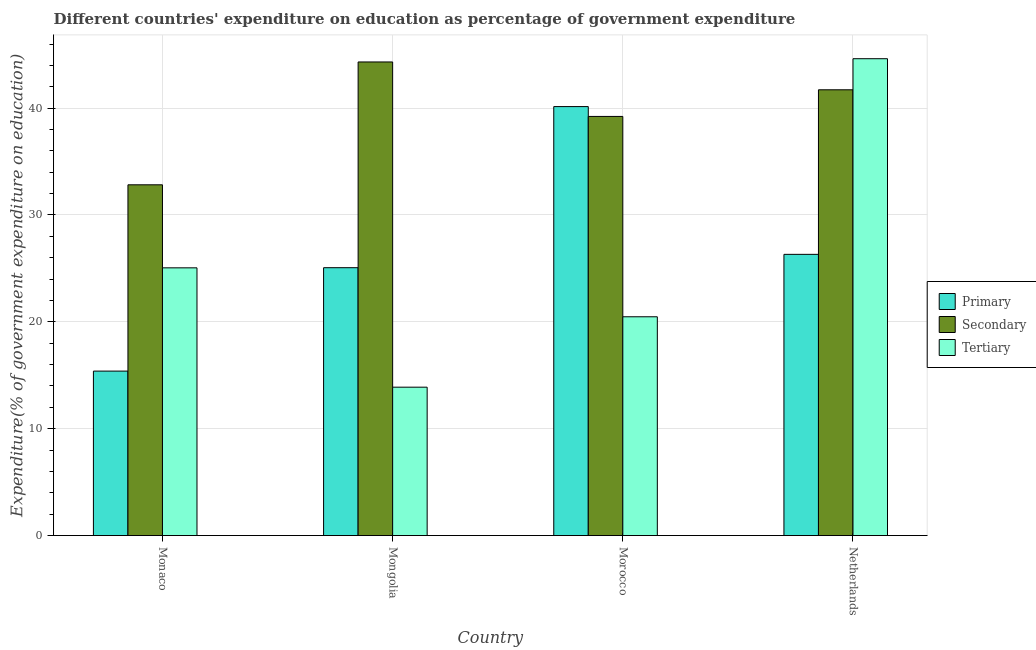How many different coloured bars are there?
Offer a very short reply. 3. Are the number of bars per tick equal to the number of legend labels?
Provide a short and direct response. Yes. Are the number of bars on each tick of the X-axis equal?
Your answer should be compact. Yes. How many bars are there on the 3rd tick from the right?
Provide a short and direct response. 3. What is the label of the 3rd group of bars from the left?
Keep it short and to the point. Morocco. In how many cases, is the number of bars for a given country not equal to the number of legend labels?
Your answer should be compact. 0. What is the expenditure on secondary education in Monaco?
Ensure brevity in your answer.  32.83. Across all countries, what is the maximum expenditure on tertiary education?
Ensure brevity in your answer.  44.63. Across all countries, what is the minimum expenditure on primary education?
Make the answer very short. 15.39. In which country was the expenditure on tertiary education maximum?
Your answer should be compact. Netherlands. In which country was the expenditure on secondary education minimum?
Your response must be concise. Monaco. What is the total expenditure on primary education in the graph?
Your answer should be compact. 106.92. What is the difference between the expenditure on secondary education in Mongolia and that in Netherlands?
Your response must be concise. 2.6. What is the difference between the expenditure on secondary education in Morocco and the expenditure on primary education in Monaco?
Your response must be concise. 23.83. What is the average expenditure on primary education per country?
Keep it short and to the point. 26.73. What is the difference between the expenditure on primary education and expenditure on tertiary education in Netherlands?
Offer a terse response. -18.31. What is the ratio of the expenditure on primary education in Monaco to that in Netherlands?
Provide a succinct answer. 0.58. Is the expenditure on primary education in Monaco less than that in Morocco?
Keep it short and to the point. Yes. Is the difference between the expenditure on primary education in Mongolia and Netherlands greater than the difference between the expenditure on secondary education in Mongolia and Netherlands?
Ensure brevity in your answer.  No. What is the difference between the highest and the second highest expenditure on tertiary education?
Give a very brief answer. 19.57. What is the difference between the highest and the lowest expenditure on tertiary education?
Your answer should be compact. 30.74. In how many countries, is the expenditure on secondary education greater than the average expenditure on secondary education taken over all countries?
Keep it short and to the point. 2. What does the 1st bar from the left in Morocco represents?
Keep it short and to the point. Primary. What does the 3rd bar from the right in Netherlands represents?
Your answer should be compact. Primary. Are all the bars in the graph horizontal?
Give a very brief answer. No. How many countries are there in the graph?
Provide a short and direct response. 4. What is the difference between two consecutive major ticks on the Y-axis?
Make the answer very short. 10. Are the values on the major ticks of Y-axis written in scientific E-notation?
Provide a short and direct response. No. What is the title of the graph?
Your response must be concise. Different countries' expenditure on education as percentage of government expenditure. Does "Poland" appear as one of the legend labels in the graph?
Keep it short and to the point. No. What is the label or title of the X-axis?
Your response must be concise. Country. What is the label or title of the Y-axis?
Give a very brief answer. Expenditure(% of government expenditure on education). What is the Expenditure(% of government expenditure on education) of Primary in Monaco?
Give a very brief answer. 15.39. What is the Expenditure(% of government expenditure on education) in Secondary in Monaco?
Offer a very short reply. 32.83. What is the Expenditure(% of government expenditure on education) in Tertiary in Monaco?
Give a very brief answer. 25.05. What is the Expenditure(% of government expenditure on education) in Primary in Mongolia?
Offer a terse response. 25.07. What is the Expenditure(% of government expenditure on education) of Secondary in Mongolia?
Make the answer very short. 44.32. What is the Expenditure(% of government expenditure on education) in Tertiary in Mongolia?
Provide a succinct answer. 13.89. What is the Expenditure(% of government expenditure on education) of Primary in Morocco?
Provide a short and direct response. 40.15. What is the Expenditure(% of government expenditure on education) of Secondary in Morocco?
Ensure brevity in your answer.  39.22. What is the Expenditure(% of government expenditure on education) of Tertiary in Morocco?
Offer a very short reply. 20.47. What is the Expenditure(% of government expenditure on education) in Primary in Netherlands?
Keep it short and to the point. 26.32. What is the Expenditure(% of government expenditure on education) of Secondary in Netherlands?
Keep it short and to the point. 41.72. What is the Expenditure(% of government expenditure on education) of Tertiary in Netherlands?
Offer a terse response. 44.63. Across all countries, what is the maximum Expenditure(% of government expenditure on education) of Primary?
Your response must be concise. 40.15. Across all countries, what is the maximum Expenditure(% of government expenditure on education) of Secondary?
Offer a terse response. 44.32. Across all countries, what is the maximum Expenditure(% of government expenditure on education) in Tertiary?
Keep it short and to the point. 44.63. Across all countries, what is the minimum Expenditure(% of government expenditure on education) of Primary?
Keep it short and to the point. 15.39. Across all countries, what is the minimum Expenditure(% of government expenditure on education) of Secondary?
Keep it short and to the point. 32.83. Across all countries, what is the minimum Expenditure(% of government expenditure on education) of Tertiary?
Provide a short and direct response. 13.89. What is the total Expenditure(% of government expenditure on education) in Primary in the graph?
Offer a very short reply. 106.92. What is the total Expenditure(% of government expenditure on education) in Secondary in the graph?
Provide a short and direct response. 158.09. What is the total Expenditure(% of government expenditure on education) in Tertiary in the graph?
Provide a short and direct response. 104.04. What is the difference between the Expenditure(% of government expenditure on education) of Primary in Monaco and that in Mongolia?
Give a very brief answer. -9.68. What is the difference between the Expenditure(% of government expenditure on education) in Secondary in Monaco and that in Mongolia?
Make the answer very short. -11.5. What is the difference between the Expenditure(% of government expenditure on education) of Tertiary in Monaco and that in Mongolia?
Your answer should be very brief. 11.17. What is the difference between the Expenditure(% of government expenditure on education) in Primary in Monaco and that in Morocco?
Keep it short and to the point. -24.75. What is the difference between the Expenditure(% of government expenditure on education) in Secondary in Monaco and that in Morocco?
Provide a succinct answer. -6.4. What is the difference between the Expenditure(% of government expenditure on education) of Tertiary in Monaco and that in Morocco?
Provide a succinct answer. 4.58. What is the difference between the Expenditure(% of government expenditure on education) in Primary in Monaco and that in Netherlands?
Your answer should be compact. -10.93. What is the difference between the Expenditure(% of government expenditure on education) of Secondary in Monaco and that in Netherlands?
Your response must be concise. -8.89. What is the difference between the Expenditure(% of government expenditure on education) in Tertiary in Monaco and that in Netherlands?
Make the answer very short. -19.57. What is the difference between the Expenditure(% of government expenditure on education) of Primary in Mongolia and that in Morocco?
Provide a short and direct response. -15.08. What is the difference between the Expenditure(% of government expenditure on education) in Secondary in Mongolia and that in Morocco?
Your response must be concise. 5.1. What is the difference between the Expenditure(% of government expenditure on education) of Tertiary in Mongolia and that in Morocco?
Your response must be concise. -6.59. What is the difference between the Expenditure(% of government expenditure on education) of Primary in Mongolia and that in Netherlands?
Your answer should be compact. -1.25. What is the difference between the Expenditure(% of government expenditure on education) of Secondary in Mongolia and that in Netherlands?
Your answer should be very brief. 2.6. What is the difference between the Expenditure(% of government expenditure on education) in Tertiary in Mongolia and that in Netherlands?
Provide a short and direct response. -30.74. What is the difference between the Expenditure(% of government expenditure on education) of Primary in Morocco and that in Netherlands?
Keep it short and to the point. 13.83. What is the difference between the Expenditure(% of government expenditure on education) of Secondary in Morocco and that in Netherlands?
Offer a terse response. -2.49. What is the difference between the Expenditure(% of government expenditure on education) of Tertiary in Morocco and that in Netherlands?
Give a very brief answer. -24.15. What is the difference between the Expenditure(% of government expenditure on education) of Primary in Monaco and the Expenditure(% of government expenditure on education) of Secondary in Mongolia?
Keep it short and to the point. -28.93. What is the difference between the Expenditure(% of government expenditure on education) of Primary in Monaco and the Expenditure(% of government expenditure on education) of Tertiary in Mongolia?
Make the answer very short. 1.5. What is the difference between the Expenditure(% of government expenditure on education) of Secondary in Monaco and the Expenditure(% of government expenditure on education) of Tertiary in Mongolia?
Offer a terse response. 18.94. What is the difference between the Expenditure(% of government expenditure on education) in Primary in Monaco and the Expenditure(% of government expenditure on education) in Secondary in Morocco?
Ensure brevity in your answer.  -23.83. What is the difference between the Expenditure(% of government expenditure on education) in Primary in Monaco and the Expenditure(% of government expenditure on education) in Tertiary in Morocco?
Make the answer very short. -5.08. What is the difference between the Expenditure(% of government expenditure on education) in Secondary in Monaco and the Expenditure(% of government expenditure on education) in Tertiary in Morocco?
Keep it short and to the point. 12.35. What is the difference between the Expenditure(% of government expenditure on education) of Primary in Monaco and the Expenditure(% of government expenditure on education) of Secondary in Netherlands?
Provide a succinct answer. -26.33. What is the difference between the Expenditure(% of government expenditure on education) of Primary in Monaco and the Expenditure(% of government expenditure on education) of Tertiary in Netherlands?
Make the answer very short. -29.23. What is the difference between the Expenditure(% of government expenditure on education) in Secondary in Monaco and the Expenditure(% of government expenditure on education) in Tertiary in Netherlands?
Ensure brevity in your answer.  -11.8. What is the difference between the Expenditure(% of government expenditure on education) in Primary in Mongolia and the Expenditure(% of government expenditure on education) in Secondary in Morocco?
Your answer should be compact. -14.16. What is the difference between the Expenditure(% of government expenditure on education) of Primary in Mongolia and the Expenditure(% of government expenditure on education) of Tertiary in Morocco?
Provide a succinct answer. 4.59. What is the difference between the Expenditure(% of government expenditure on education) of Secondary in Mongolia and the Expenditure(% of government expenditure on education) of Tertiary in Morocco?
Provide a succinct answer. 23.85. What is the difference between the Expenditure(% of government expenditure on education) of Primary in Mongolia and the Expenditure(% of government expenditure on education) of Secondary in Netherlands?
Keep it short and to the point. -16.65. What is the difference between the Expenditure(% of government expenditure on education) in Primary in Mongolia and the Expenditure(% of government expenditure on education) in Tertiary in Netherlands?
Provide a short and direct response. -19.56. What is the difference between the Expenditure(% of government expenditure on education) in Secondary in Mongolia and the Expenditure(% of government expenditure on education) in Tertiary in Netherlands?
Ensure brevity in your answer.  -0.3. What is the difference between the Expenditure(% of government expenditure on education) in Primary in Morocco and the Expenditure(% of government expenditure on education) in Secondary in Netherlands?
Your response must be concise. -1.57. What is the difference between the Expenditure(% of government expenditure on education) of Primary in Morocco and the Expenditure(% of government expenditure on education) of Tertiary in Netherlands?
Your response must be concise. -4.48. What is the difference between the Expenditure(% of government expenditure on education) of Secondary in Morocco and the Expenditure(% of government expenditure on education) of Tertiary in Netherlands?
Your response must be concise. -5.4. What is the average Expenditure(% of government expenditure on education) of Primary per country?
Make the answer very short. 26.73. What is the average Expenditure(% of government expenditure on education) in Secondary per country?
Your response must be concise. 39.52. What is the average Expenditure(% of government expenditure on education) of Tertiary per country?
Offer a very short reply. 26.01. What is the difference between the Expenditure(% of government expenditure on education) of Primary and Expenditure(% of government expenditure on education) of Secondary in Monaco?
Give a very brief answer. -17.43. What is the difference between the Expenditure(% of government expenditure on education) of Primary and Expenditure(% of government expenditure on education) of Tertiary in Monaco?
Ensure brevity in your answer.  -9.66. What is the difference between the Expenditure(% of government expenditure on education) in Secondary and Expenditure(% of government expenditure on education) in Tertiary in Monaco?
Your answer should be very brief. 7.77. What is the difference between the Expenditure(% of government expenditure on education) of Primary and Expenditure(% of government expenditure on education) of Secondary in Mongolia?
Ensure brevity in your answer.  -19.25. What is the difference between the Expenditure(% of government expenditure on education) of Primary and Expenditure(% of government expenditure on education) of Tertiary in Mongolia?
Provide a short and direct response. 11.18. What is the difference between the Expenditure(% of government expenditure on education) in Secondary and Expenditure(% of government expenditure on education) in Tertiary in Mongolia?
Your answer should be compact. 30.43. What is the difference between the Expenditure(% of government expenditure on education) in Primary and Expenditure(% of government expenditure on education) in Secondary in Morocco?
Your answer should be very brief. 0.92. What is the difference between the Expenditure(% of government expenditure on education) in Primary and Expenditure(% of government expenditure on education) in Tertiary in Morocco?
Keep it short and to the point. 19.67. What is the difference between the Expenditure(% of government expenditure on education) in Secondary and Expenditure(% of government expenditure on education) in Tertiary in Morocco?
Offer a very short reply. 18.75. What is the difference between the Expenditure(% of government expenditure on education) in Primary and Expenditure(% of government expenditure on education) in Secondary in Netherlands?
Offer a terse response. -15.4. What is the difference between the Expenditure(% of government expenditure on education) in Primary and Expenditure(% of government expenditure on education) in Tertiary in Netherlands?
Offer a terse response. -18.31. What is the difference between the Expenditure(% of government expenditure on education) of Secondary and Expenditure(% of government expenditure on education) of Tertiary in Netherlands?
Provide a succinct answer. -2.91. What is the ratio of the Expenditure(% of government expenditure on education) of Primary in Monaco to that in Mongolia?
Provide a succinct answer. 0.61. What is the ratio of the Expenditure(% of government expenditure on education) of Secondary in Monaco to that in Mongolia?
Provide a short and direct response. 0.74. What is the ratio of the Expenditure(% of government expenditure on education) of Tertiary in Monaco to that in Mongolia?
Your response must be concise. 1.8. What is the ratio of the Expenditure(% of government expenditure on education) in Primary in Monaco to that in Morocco?
Ensure brevity in your answer.  0.38. What is the ratio of the Expenditure(% of government expenditure on education) in Secondary in Monaco to that in Morocco?
Your answer should be very brief. 0.84. What is the ratio of the Expenditure(% of government expenditure on education) in Tertiary in Monaco to that in Morocco?
Offer a very short reply. 1.22. What is the ratio of the Expenditure(% of government expenditure on education) of Primary in Monaco to that in Netherlands?
Ensure brevity in your answer.  0.58. What is the ratio of the Expenditure(% of government expenditure on education) of Secondary in Monaco to that in Netherlands?
Provide a short and direct response. 0.79. What is the ratio of the Expenditure(% of government expenditure on education) in Tertiary in Monaco to that in Netherlands?
Provide a short and direct response. 0.56. What is the ratio of the Expenditure(% of government expenditure on education) in Primary in Mongolia to that in Morocco?
Make the answer very short. 0.62. What is the ratio of the Expenditure(% of government expenditure on education) of Secondary in Mongolia to that in Morocco?
Offer a very short reply. 1.13. What is the ratio of the Expenditure(% of government expenditure on education) of Tertiary in Mongolia to that in Morocco?
Give a very brief answer. 0.68. What is the ratio of the Expenditure(% of government expenditure on education) in Primary in Mongolia to that in Netherlands?
Make the answer very short. 0.95. What is the ratio of the Expenditure(% of government expenditure on education) in Secondary in Mongolia to that in Netherlands?
Ensure brevity in your answer.  1.06. What is the ratio of the Expenditure(% of government expenditure on education) of Tertiary in Mongolia to that in Netherlands?
Your answer should be very brief. 0.31. What is the ratio of the Expenditure(% of government expenditure on education) in Primary in Morocco to that in Netherlands?
Provide a succinct answer. 1.53. What is the ratio of the Expenditure(% of government expenditure on education) of Secondary in Morocco to that in Netherlands?
Offer a terse response. 0.94. What is the ratio of the Expenditure(% of government expenditure on education) in Tertiary in Morocco to that in Netherlands?
Give a very brief answer. 0.46. What is the difference between the highest and the second highest Expenditure(% of government expenditure on education) in Primary?
Keep it short and to the point. 13.83. What is the difference between the highest and the second highest Expenditure(% of government expenditure on education) in Secondary?
Offer a very short reply. 2.6. What is the difference between the highest and the second highest Expenditure(% of government expenditure on education) of Tertiary?
Your answer should be very brief. 19.57. What is the difference between the highest and the lowest Expenditure(% of government expenditure on education) of Primary?
Make the answer very short. 24.75. What is the difference between the highest and the lowest Expenditure(% of government expenditure on education) of Secondary?
Give a very brief answer. 11.5. What is the difference between the highest and the lowest Expenditure(% of government expenditure on education) in Tertiary?
Provide a short and direct response. 30.74. 